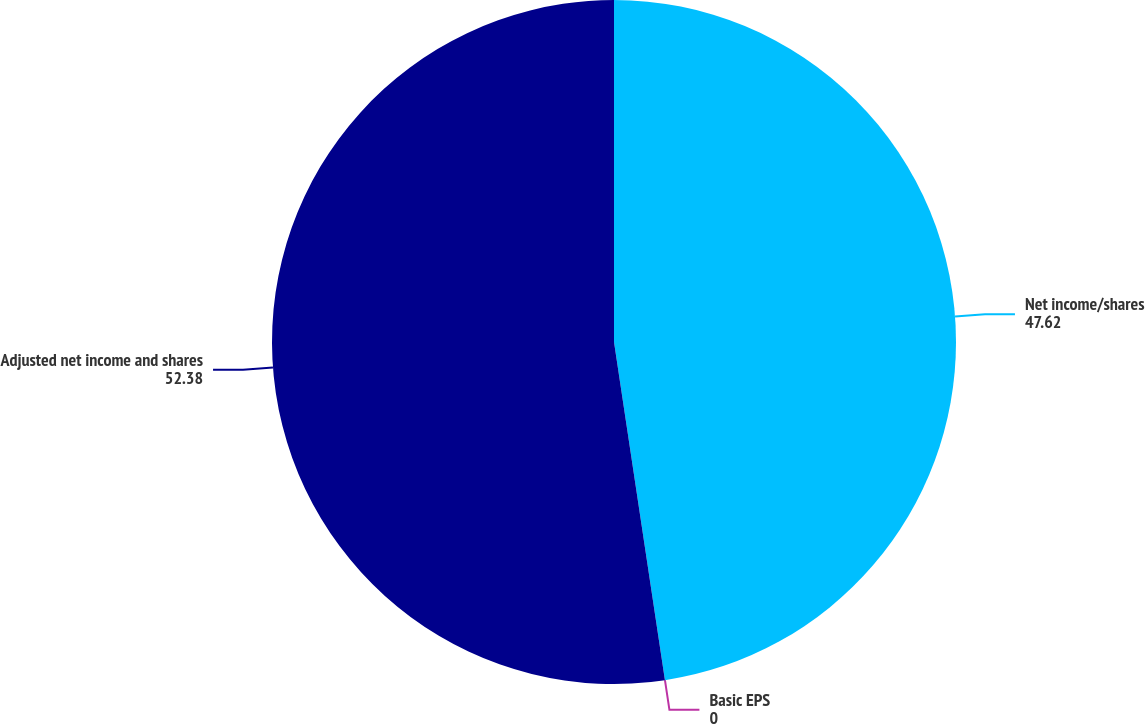Convert chart to OTSL. <chart><loc_0><loc_0><loc_500><loc_500><pie_chart><fcel>Net income/shares<fcel>Basic EPS<fcel>Adjusted net income and shares<nl><fcel>47.62%<fcel>0.0%<fcel>52.38%<nl></chart> 